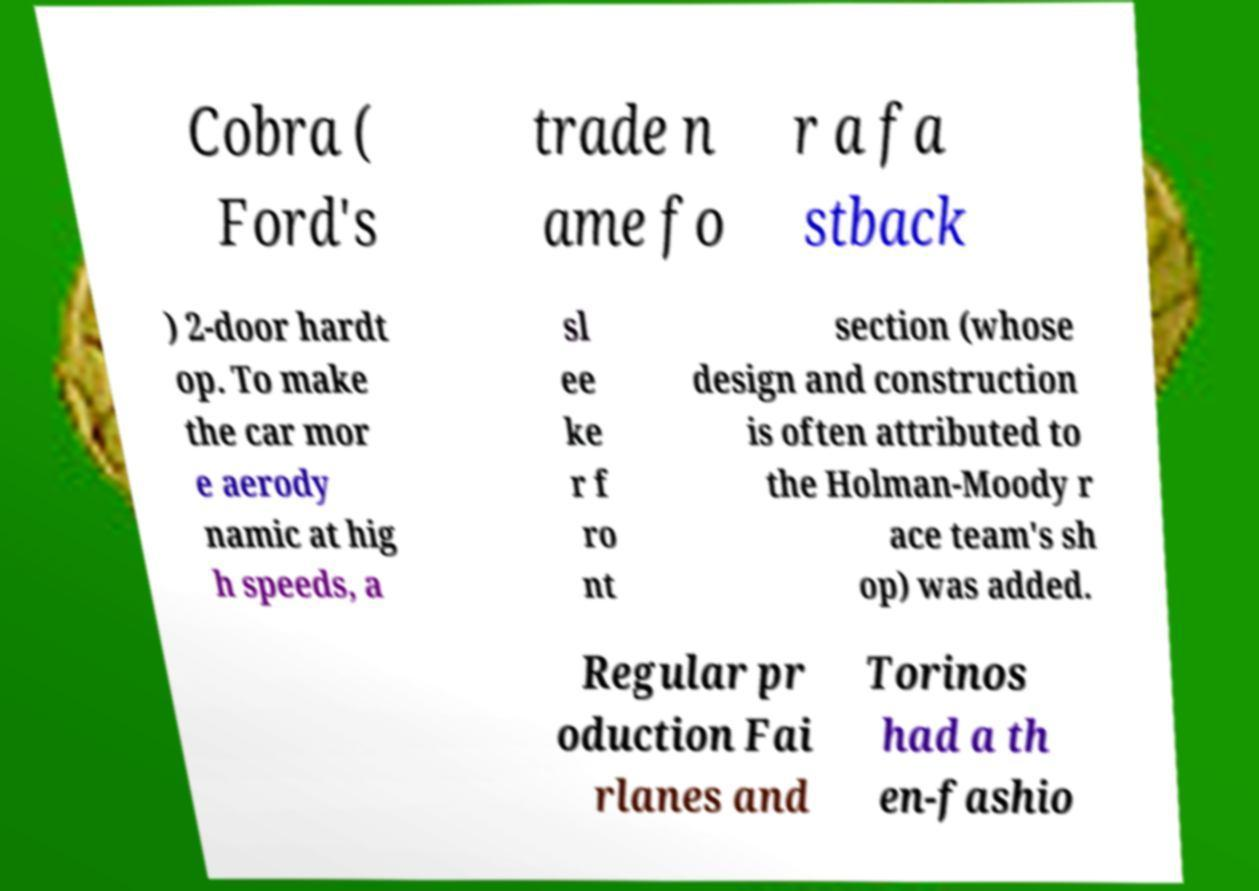I need the written content from this picture converted into text. Can you do that? Cobra ( Ford's trade n ame fo r a fa stback ) 2-door hardt op. To make the car mor e aerody namic at hig h speeds, a sl ee ke r f ro nt section (whose design and construction is often attributed to the Holman-Moody r ace team's sh op) was added. Regular pr oduction Fai rlanes and Torinos had a th en-fashio 